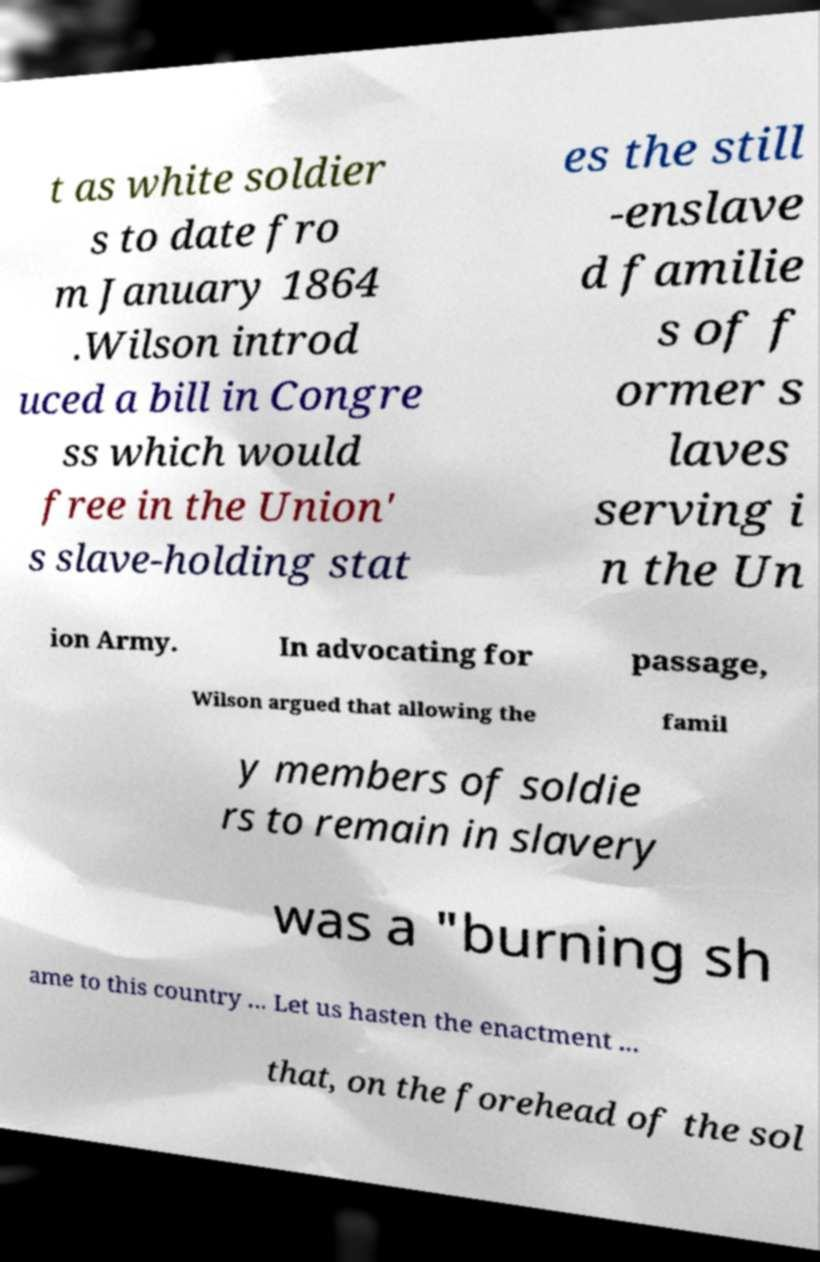Please read and relay the text visible in this image. What does it say? t as white soldier s to date fro m January 1864 .Wilson introd uced a bill in Congre ss which would free in the Union' s slave-holding stat es the still -enslave d familie s of f ormer s laves serving i n the Un ion Army. In advocating for passage, Wilson argued that allowing the famil y members of soldie rs to remain in slavery was a "burning sh ame to this country ... Let us hasten the enactment ... that, on the forehead of the sol 